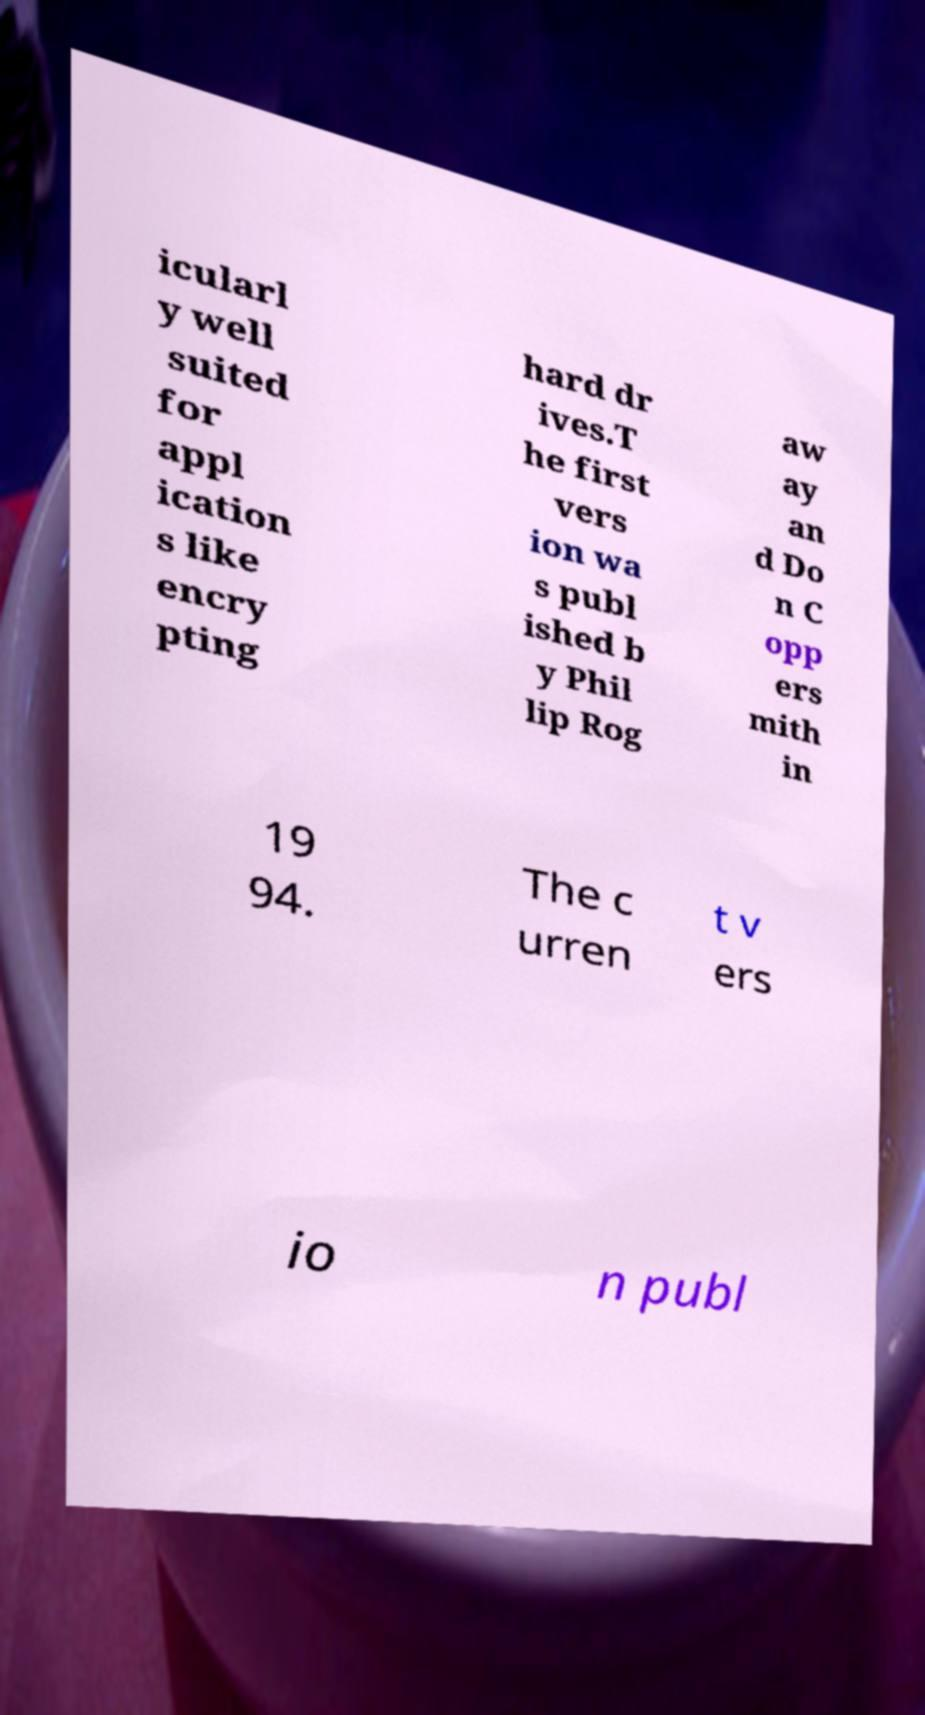I need the written content from this picture converted into text. Can you do that? icularl y well suited for appl ication s like encry pting hard dr ives.T he first vers ion wa s publ ished b y Phil lip Rog aw ay an d Do n C opp ers mith in 19 94. The c urren t v ers io n publ 